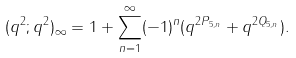<formula> <loc_0><loc_0><loc_500><loc_500>( q ^ { 2 } ; q ^ { 2 } ) _ { \infty } & = 1 + \sum _ { n = 1 } ^ { \infty } ( - 1 ) ^ { n } ( q ^ { 2 P _ { 5 , n } } + q ^ { 2 Q _ { 5 , n } } ) .</formula> 